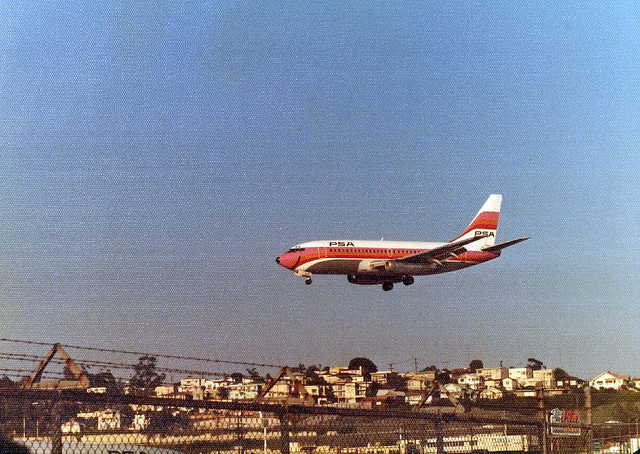What type of vehicle is pictured in the image? The image shows an airplane, specifically a commercial jet, in mid-flight. 